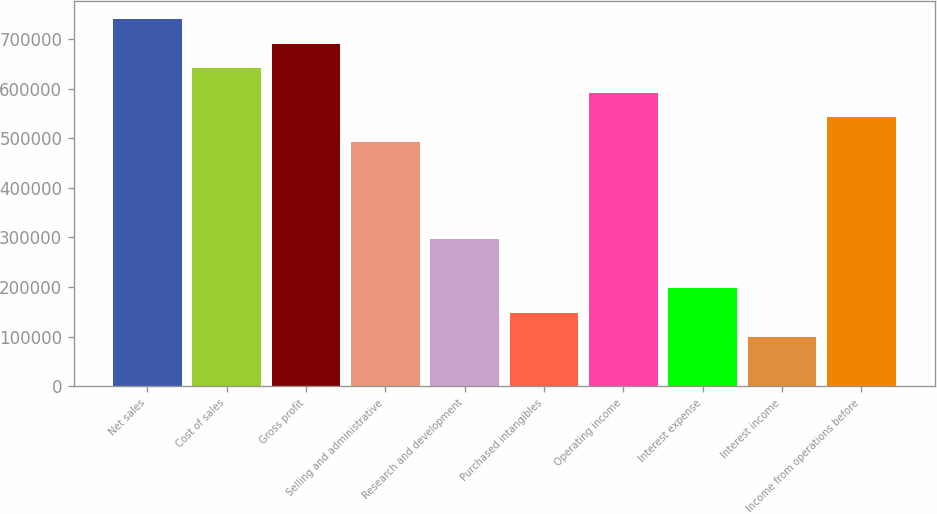<chart> <loc_0><loc_0><loc_500><loc_500><bar_chart><fcel>Net sales<fcel>Cost of sales<fcel>Gross profit<fcel>Selling and administrative<fcel>Research and development<fcel>Purchased intangibles<fcel>Operating income<fcel>Interest expense<fcel>Interest income<fcel>Income from operations before<nl><fcel>739747<fcel>641114<fcel>690431<fcel>493165<fcel>295900<fcel>147950<fcel>591798<fcel>197267<fcel>98634.1<fcel>542481<nl></chart> 